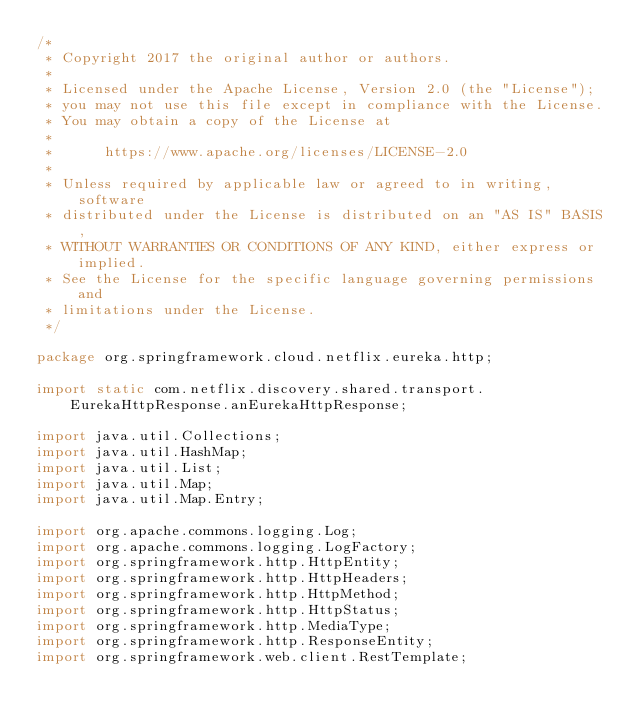<code> <loc_0><loc_0><loc_500><loc_500><_Java_>/*
 * Copyright 2017 the original author or authors.
 *
 * Licensed under the Apache License, Version 2.0 (the "License");
 * you may not use this file except in compliance with the License.
 * You may obtain a copy of the License at
 *
 *      https://www.apache.org/licenses/LICENSE-2.0
 *
 * Unless required by applicable law or agreed to in writing, software
 * distributed under the License is distributed on an "AS IS" BASIS,
 * WITHOUT WARRANTIES OR CONDITIONS OF ANY KIND, either express or implied.
 * See the License for the specific language governing permissions and
 * limitations under the License.
 */

package org.springframework.cloud.netflix.eureka.http;

import static com.netflix.discovery.shared.transport.EurekaHttpResponse.anEurekaHttpResponse;

import java.util.Collections;
import java.util.HashMap;
import java.util.List;
import java.util.Map;
import java.util.Map.Entry;

import org.apache.commons.logging.Log;
import org.apache.commons.logging.LogFactory;
import org.springframework.http.HttpEntity;
import org.springframework.http.HttpHeaders;
import org.springframework.http.HttpMethod;
import org.springframework.http.HttpStatus;
import org.springframework.http.MediaType;
import org.springframework.http.ResponseEntity;
import org.springframework.web.client.RestTemplate;
</code> 